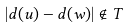Convert formula to latex. <formula><loc_0><loc_0><loc_500><loc_500>| d ( u ) - d ( w ) | \notin T</formula> 